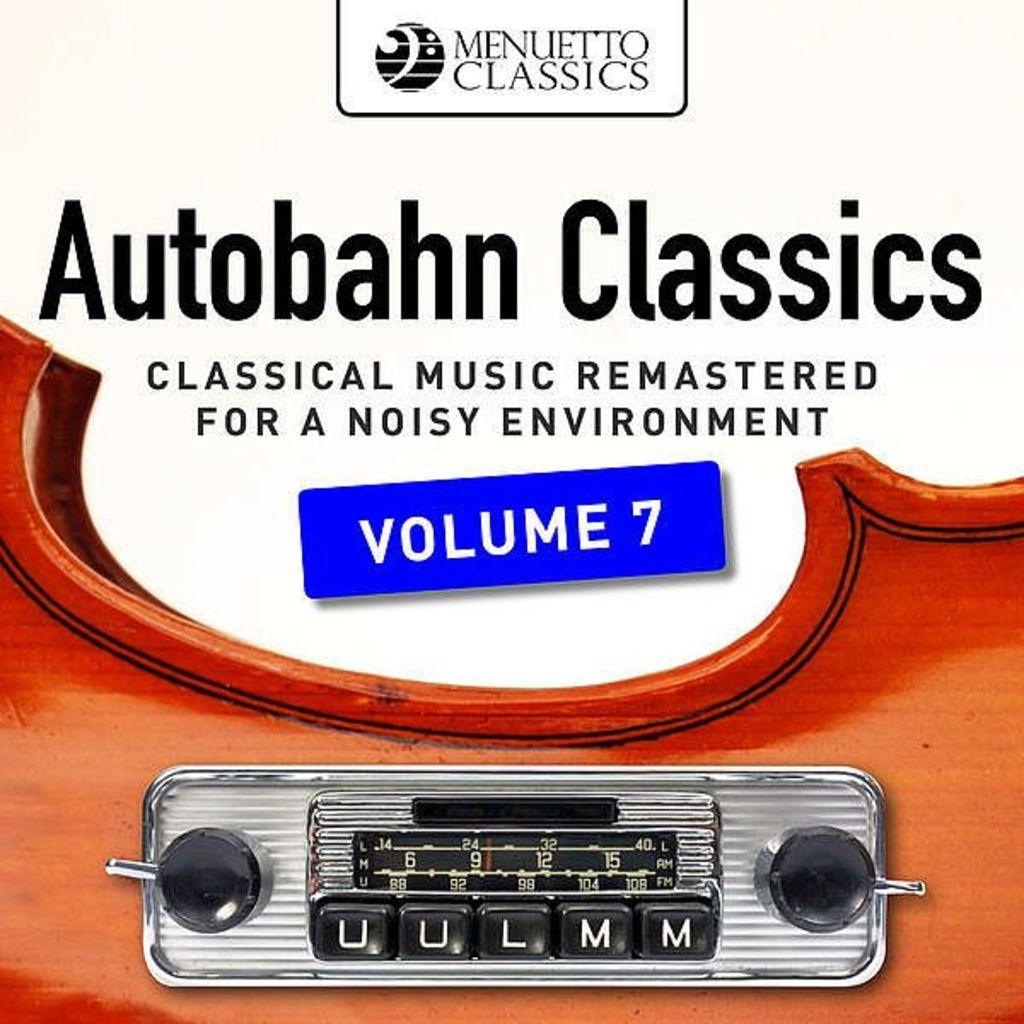What type of visual is the image? The image is a poster. What can be seen in the poster? There is a device and a wooden object depicted in the poster. Is there any text present in the poster? Yes, there is text present in the poster. Can you see any caves in the poster? There are no caves depicted in the poster. What type of cough is being advertised in the poster? There is no cough or any medical-related information in the poster. 